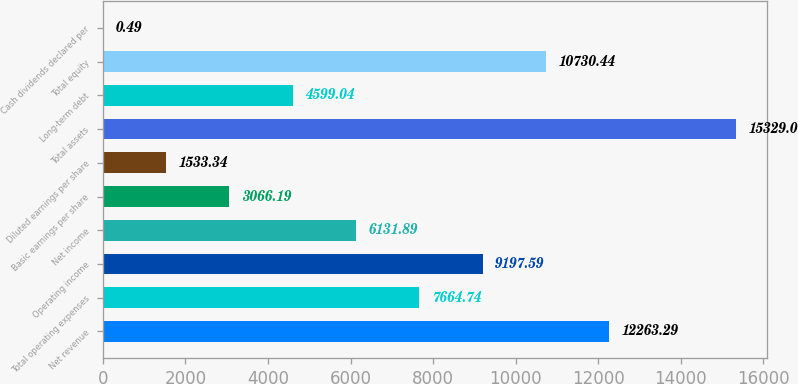Convert chart. <chart><loc_0><loc_0><loc_500><loc_500><bar_chart><fcel>Net revenue<fcel>Total operating expenses<fcel>Operating income<fcel>Net income<fcel>Basic earnings per share<fcel>Diluted earnings per share<fcel>Total assets<fcel>Long-term debt<fcel>Total equity<fcel>Cash dividends declared per<nl><fcel>12263.3<fcel>7664.74<fcel>9197.59<fcel>6131.89<fcel>3066.19<fcel>1533.34<fcel>15329<fcel>4599.04<fcel>10730.4<fcel>0.49<nl></chart> 